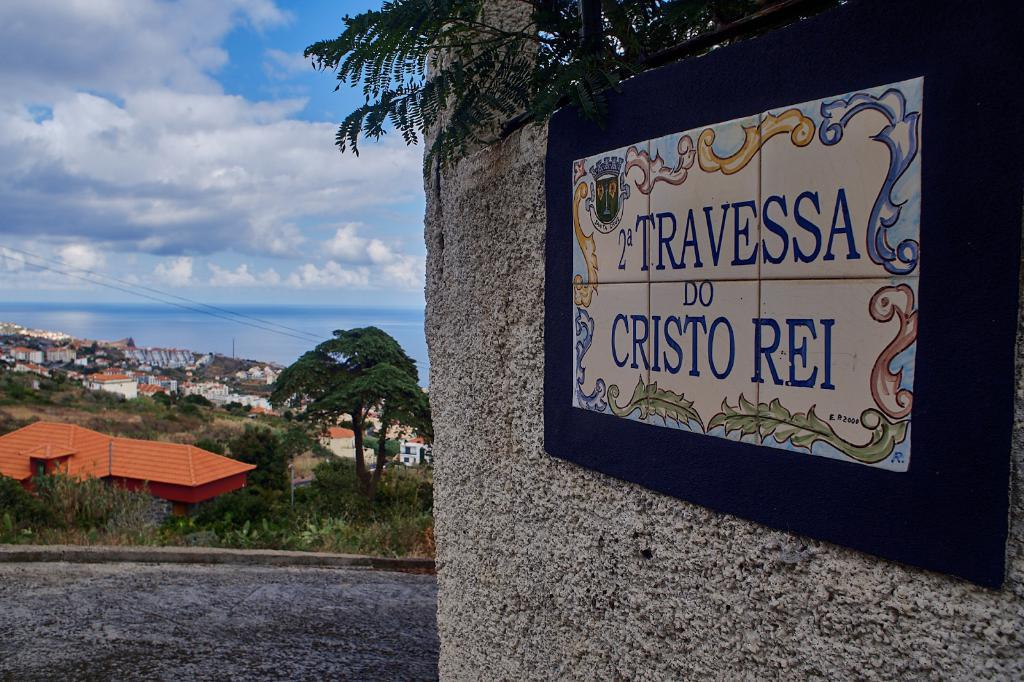What type of vegetation can be seen in the image? There are trees in the image. What type of structures are present in the image? There are sheds in the image. What is on the right side of the image? There is a wall on the right side of the image. What is attached to the wall? There is a board on the wall. What can be seen in the background of the image? The sky is visible in the background of the image. How many eggs are on the board in the image? There are no eggs present in the image. What does the board on the wall represent in terms of regret? The board on the wall does not represent any feelings of regret, as it is not mentioned in the provided facts. 